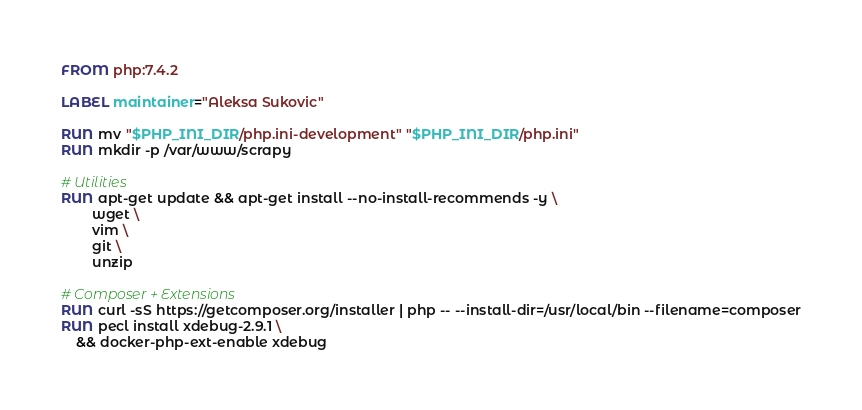Convert code to text. <code><loc_0><loc_0><loc_500><loc_500><_Dockerfile_>FROM php:7.4.2

LABEL maintainer="Aleksa Sukovic"

RUN mv "$PHP_INI_DIR/php.ini-development" "$PHP_INI_DIR/php.ini"
RUN mkdir -p /var/www/scrapy

# Utilities
RUN apt-get update && apt-get install --no-install-recommends -y \
        wget \
        vim \
        git \
        unzip

# Composer + Extensions
RUN curl -sS https://getcomposer.org/installer | php -- --install-dir=/usr/local/bin --filename=composer
RUN pecl install xdebug-2.9.1 \
    && docker-php-ext-enable xdebug

</code> 